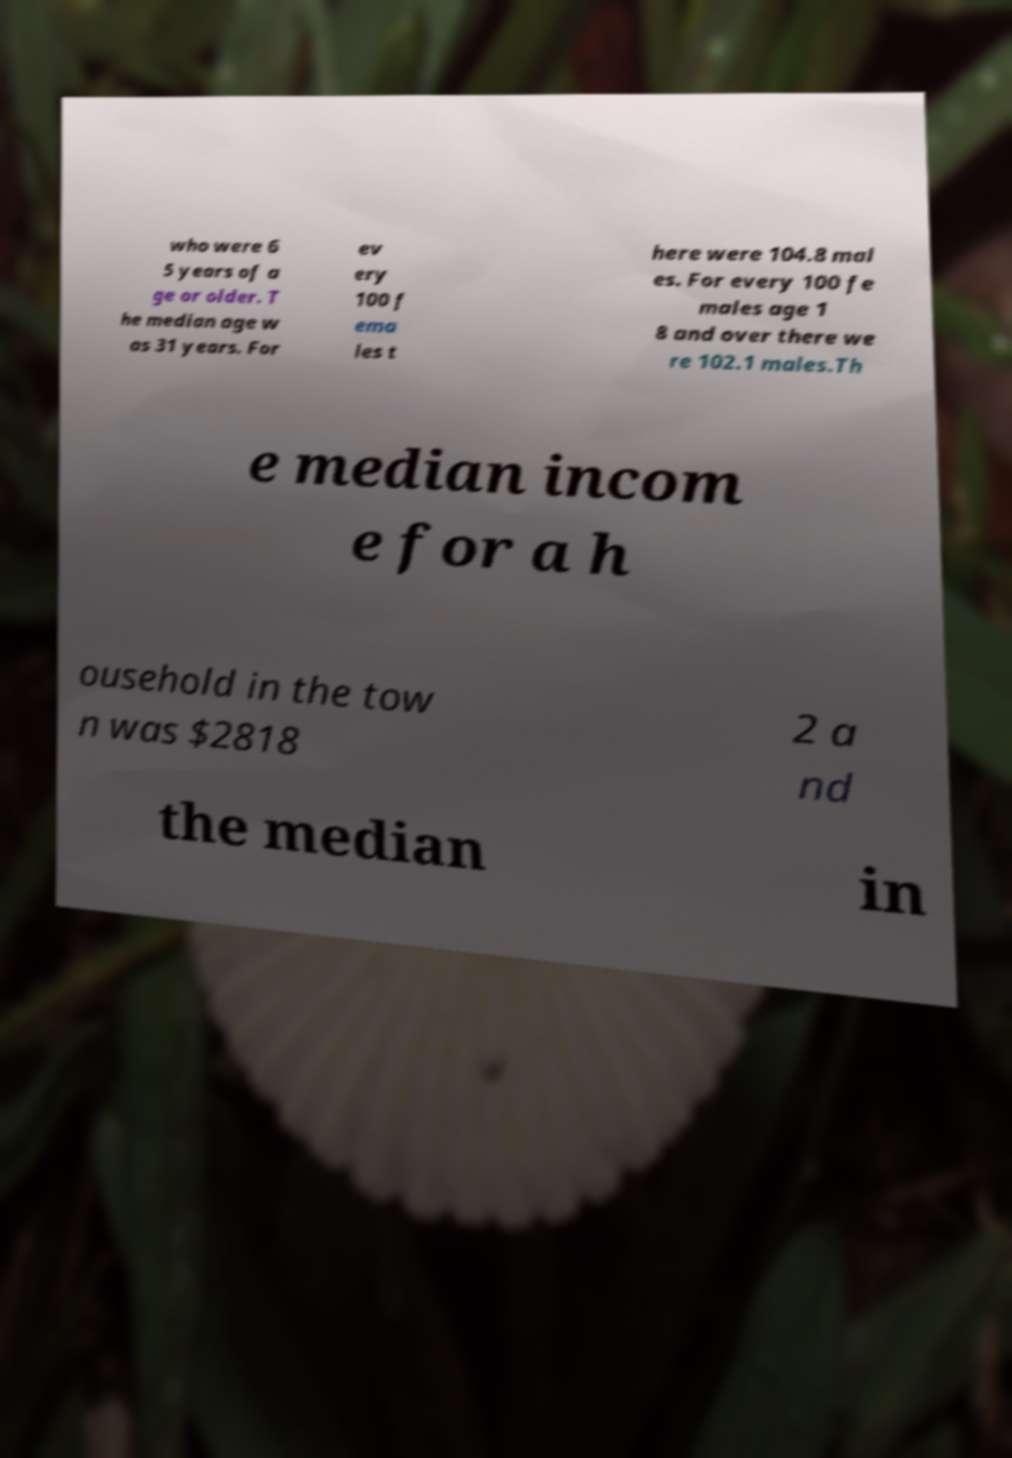Could you assist in decoding the text presented in this image and type it out clearly? who were 6 5 years of a ge or older. T he median age w as 31 years. For ev ery 100 f ema les t here were 104.8 mal es. For every 100 fe males age 1 8 and over there we re 102.1 males.Th e median incom e for a h ousehold in the tow n was $2818 2 a nd the median in 